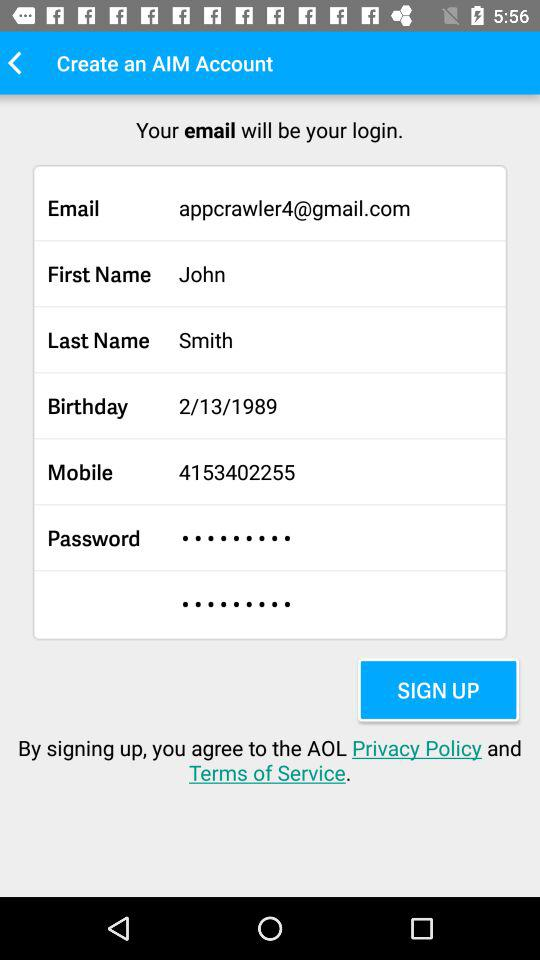What is the user's last name? The user's last name is Smith. 